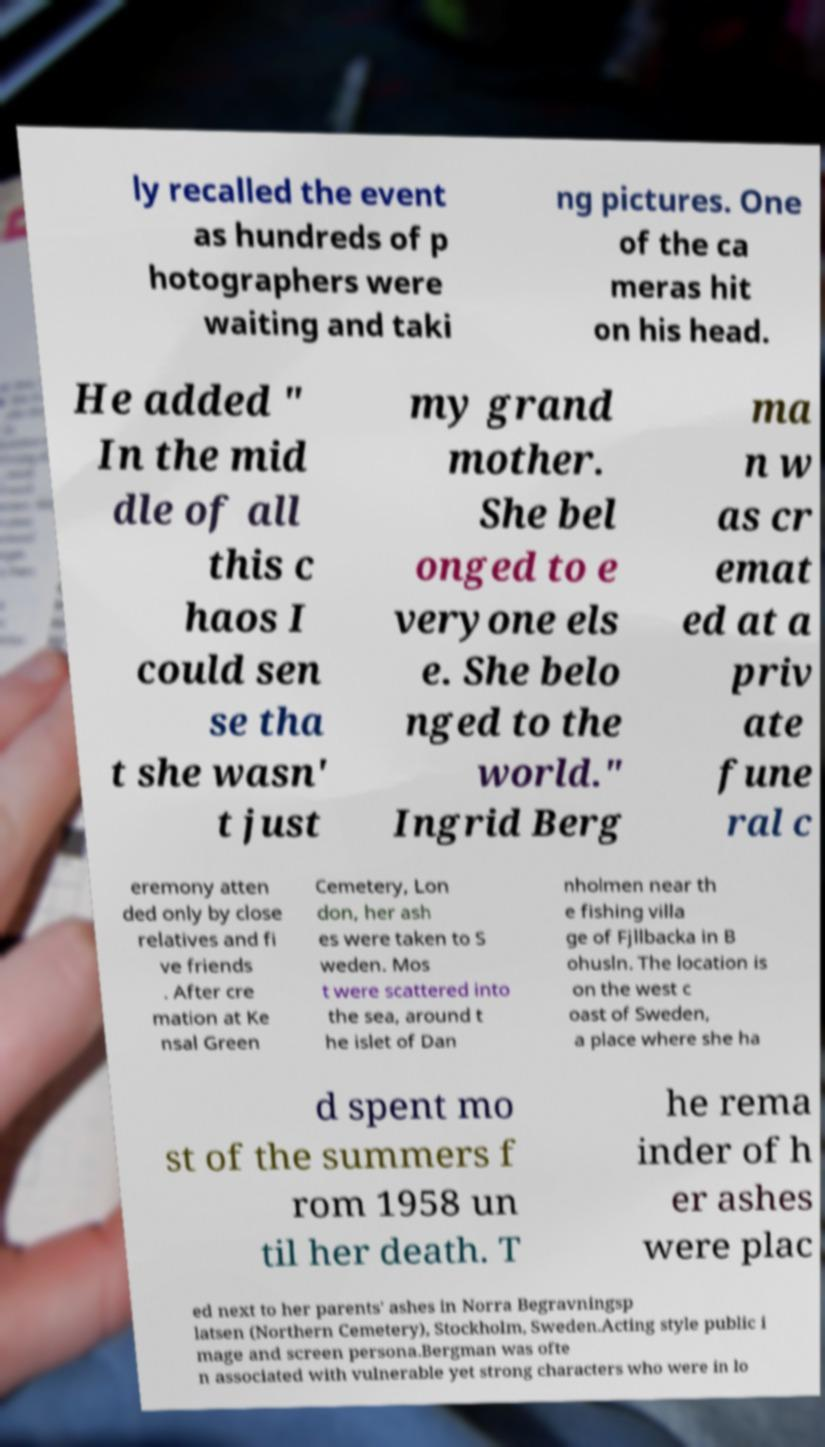Can you read and provide the text displayed in the image?This photo seems to have some interesting text. Can you extract and type it out for me? ly recalled the event as hundreds of p hotographers were waiting and taki ng pictures. One of the ca meras hit on his head. He added " In the mid dle of all this c haos I could sen se tha t she wasn' t just my grand mother. She bel onged to e veryone els e. She belo nged to the world." Ingrid Berg ma n w as cr emat ed at a priv ate fune ral c eremony atten ded only by close relatives and fi ve friends . After cre mation at Ke nsal Green Cemetery, Lon don, her ash es were taken to S weden. Mos t were scattered into the sea, around t he islet of Dan nholmen near th e fishing villa ge of Fjllbacka in B ohusln. The location is on the west c oast of Sweden, a place where she ha d spent mo st of the summers f rom 1958 un til her death. T he rema inder of h er ashes were plac ed next to her parents' ashes in Norra Begravningsp latsen (Northern Cemetery), Stockholm, Sweden.Acting style public i mage and screen persona.Bergman was ofte n associated with vulnerable yet strong characters who were in lo 